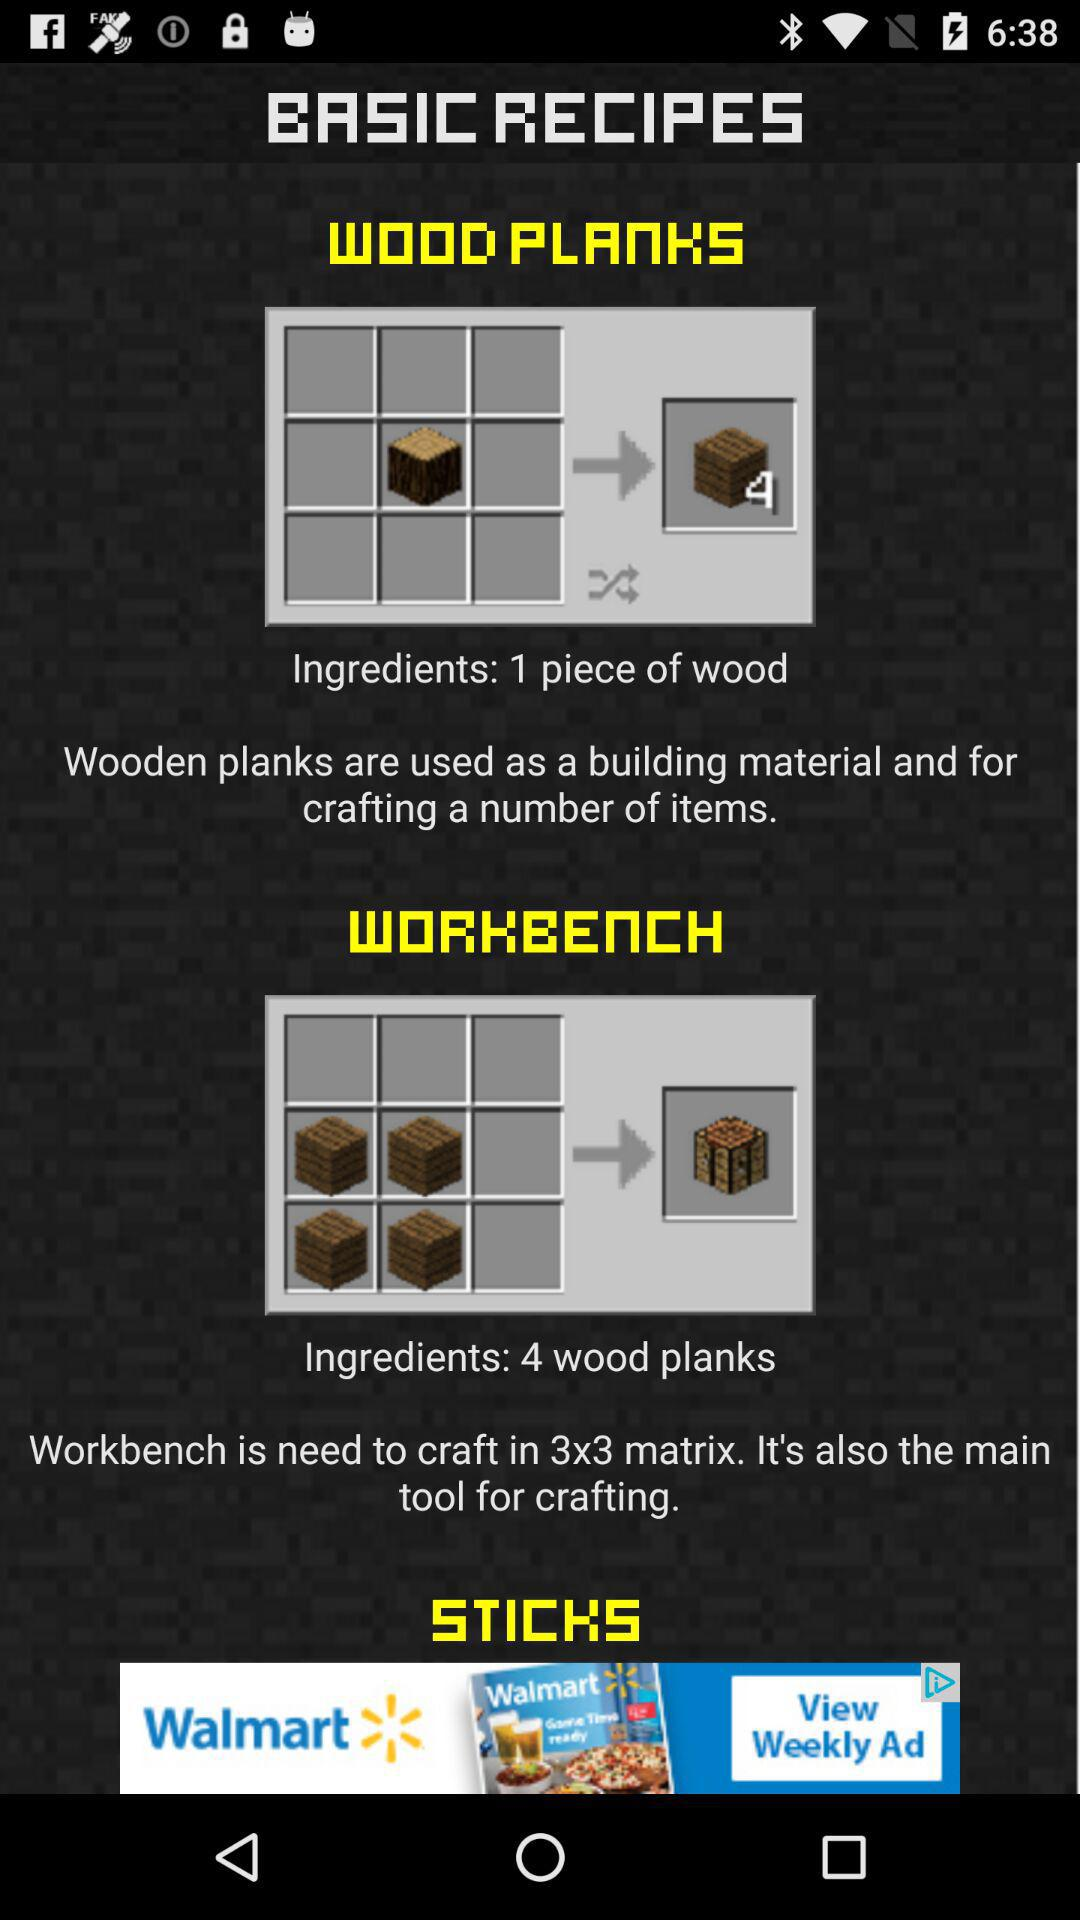How many more ingredients are needed to craft a workbench than wood planks?
Answer the question using a single word or phrase. 3 